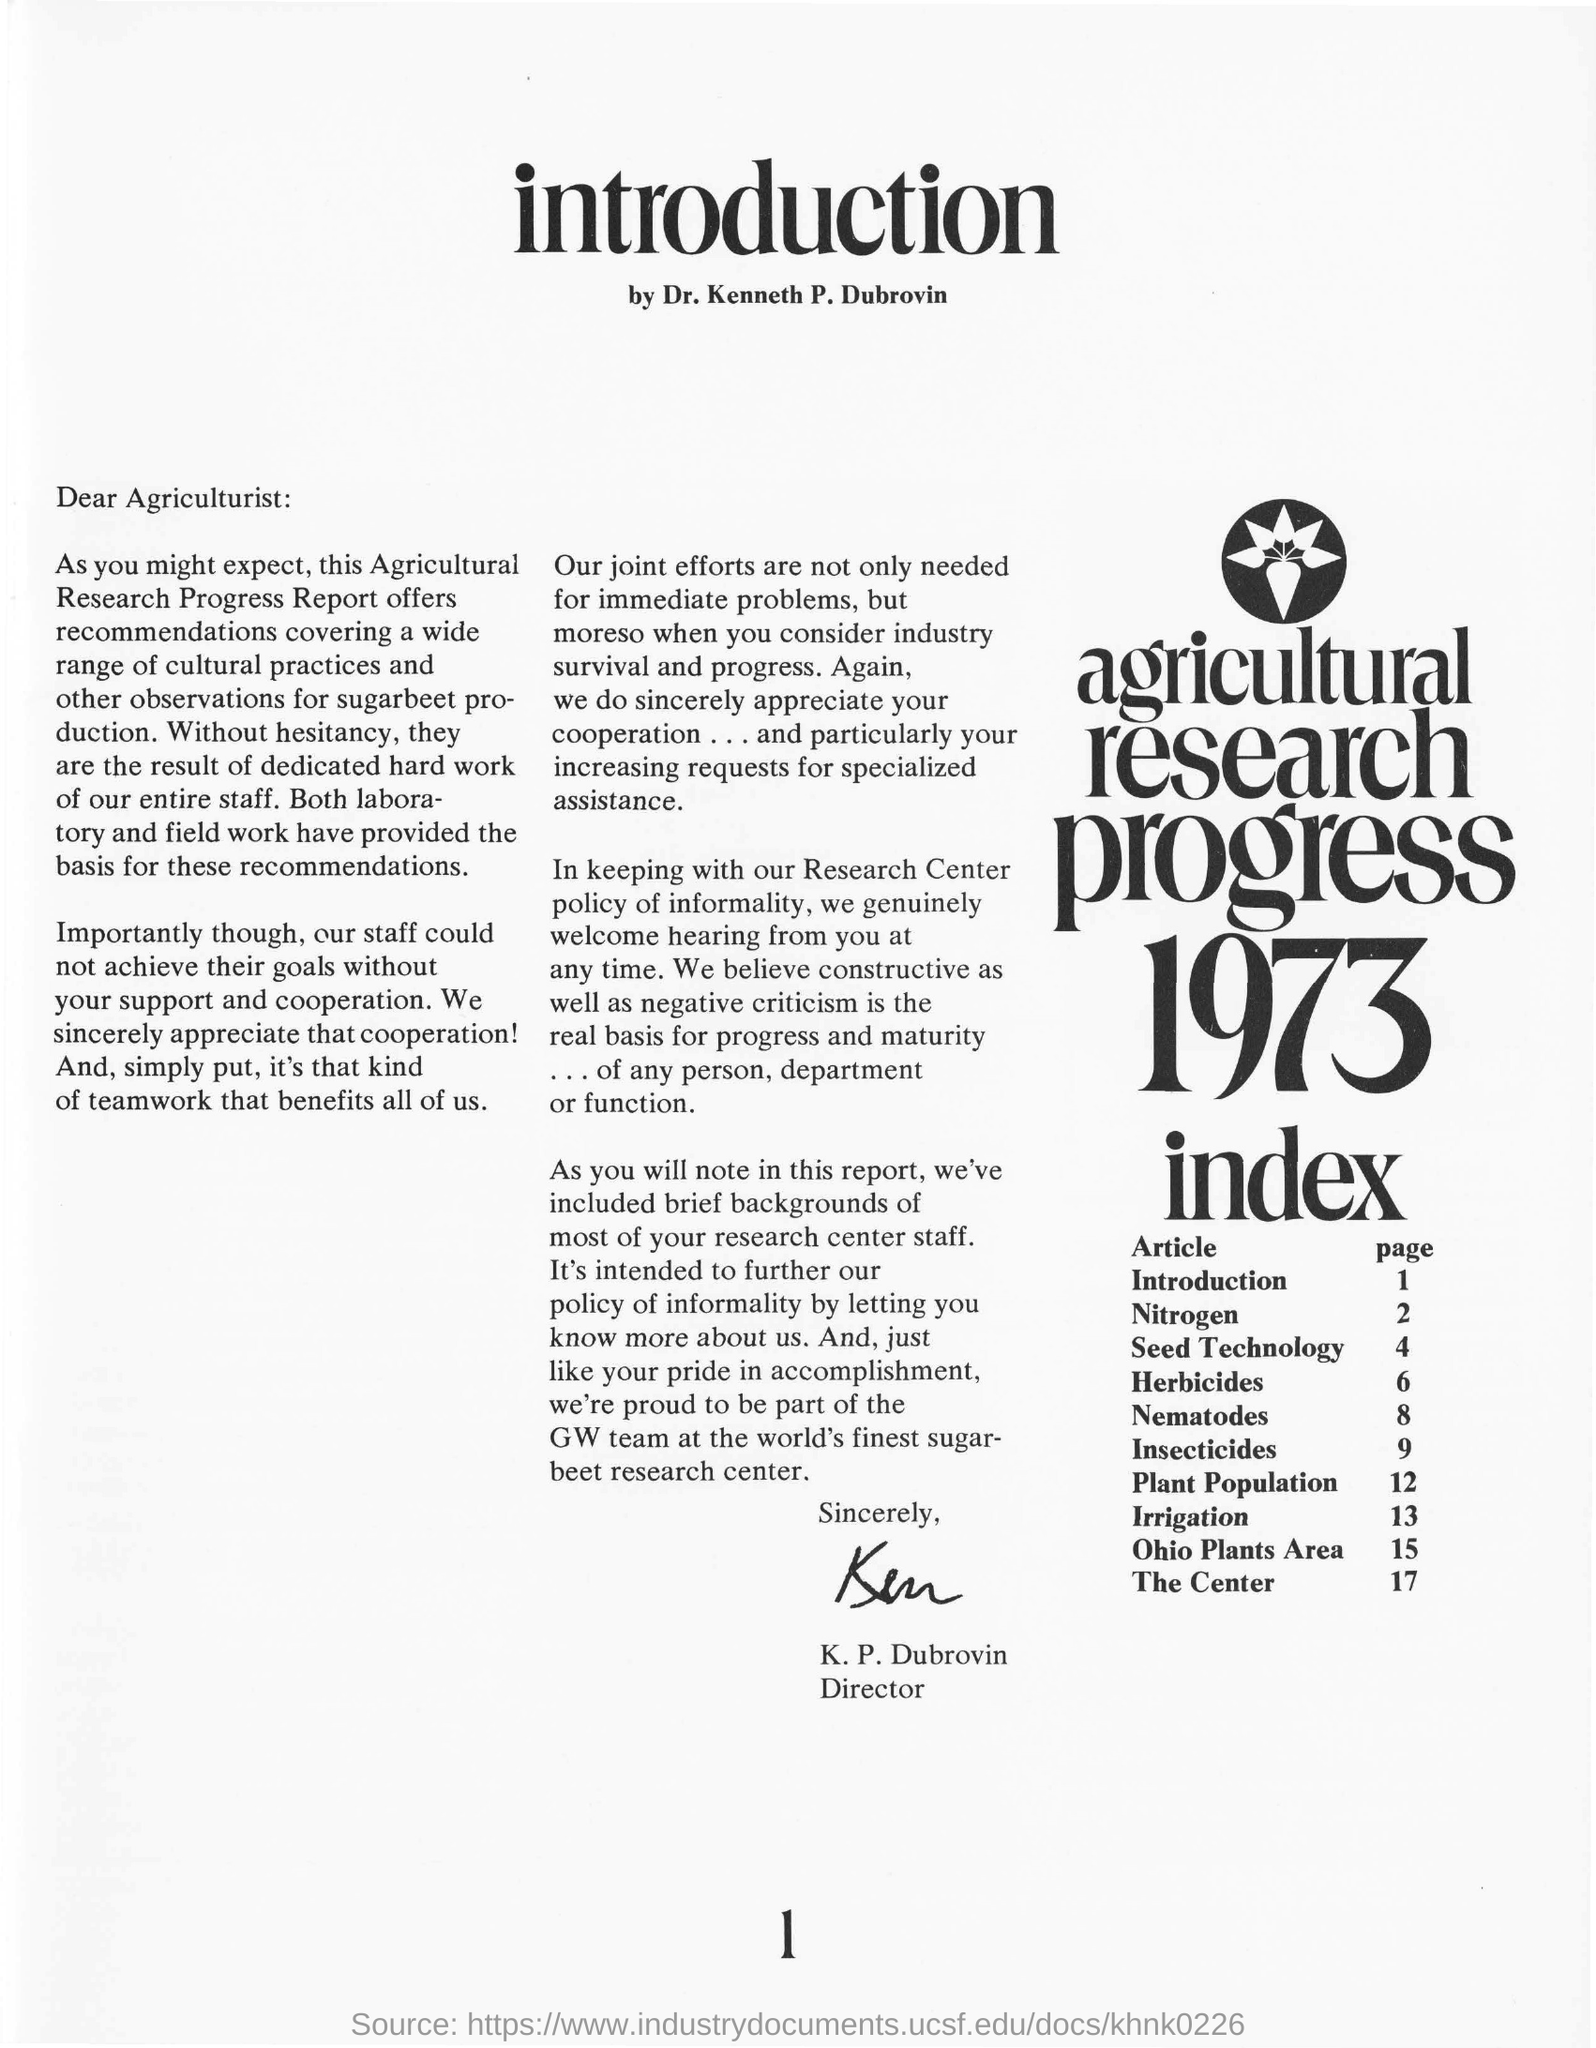Give some essential details in this illustration. K.P. Dubrovin wrote the current piece. The topic of plant population is located on page 12 of the given page number. The report discusses irrigation on page 13. This document is addressed to an individual identified as an agriculturist. 